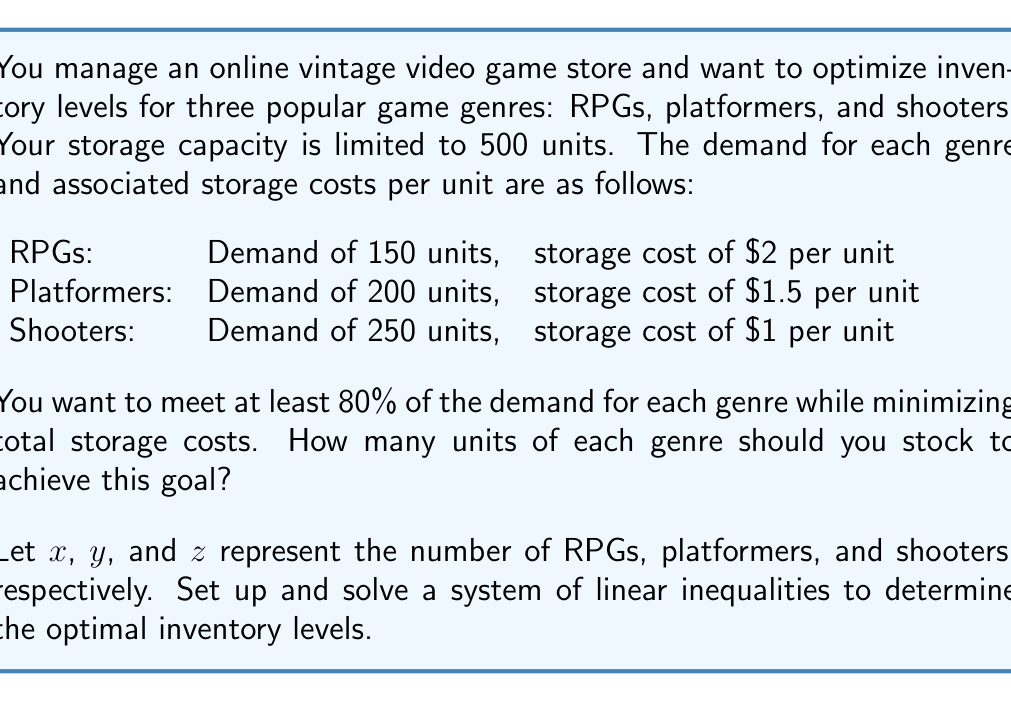Help me with this question. Let's approach this step-by-step:

1) First, we set up the constraints based on the given information:

   a) Storage capacity: $x + y + z \leq 500$
   b) Minimum demand for RPGs: $x \geq 0.8 \times 150 = 120$
   c) Minimum demand for platformers: $y \geq 0.8 \times 200 = 160$
   d) Minimum demand for shooters: $z \geq 0.8 \times 250 = 200$

2) Our objective is to minimize the total storage cost, which can be expressed as:

   $\text{Total Cost} = 2x + 1.5y + z$

3) We now have a linear programming problem. To solve it, we can use the corner point method, as the optimal solution will be at one of the vertices of the feasible region.

4) The vertices of our feasible region are the points where the constraints intersect. We need to consider these points:

   (120, 160, 200), (120, 160, 220), (120, 180, 200), (140, 160, 200)

5) Let's calculate the total cost for each point:

   (120, 160, 200): $2(120) + 1.5(160) + 200 = 680$
   (120, 160, 220): $2(120) + 1.5(160) + 220 = 700$
   (120, 180, 200): $2(120) + 1.5(180) + 200 = 710$
   (140, 160, 200): $2(140) + 1.5(160) + 200 = 720$

6) The point with the minimum cost is (120, 160, 200), which corresponds to:
   120 RPGs, 160 platformers, and 200 shooters.

This solution meets the minimum demand requirements for each genre and minimizes the total storage cost.
Answer: 120 RPGs, 160 platformers, 200 shooters 